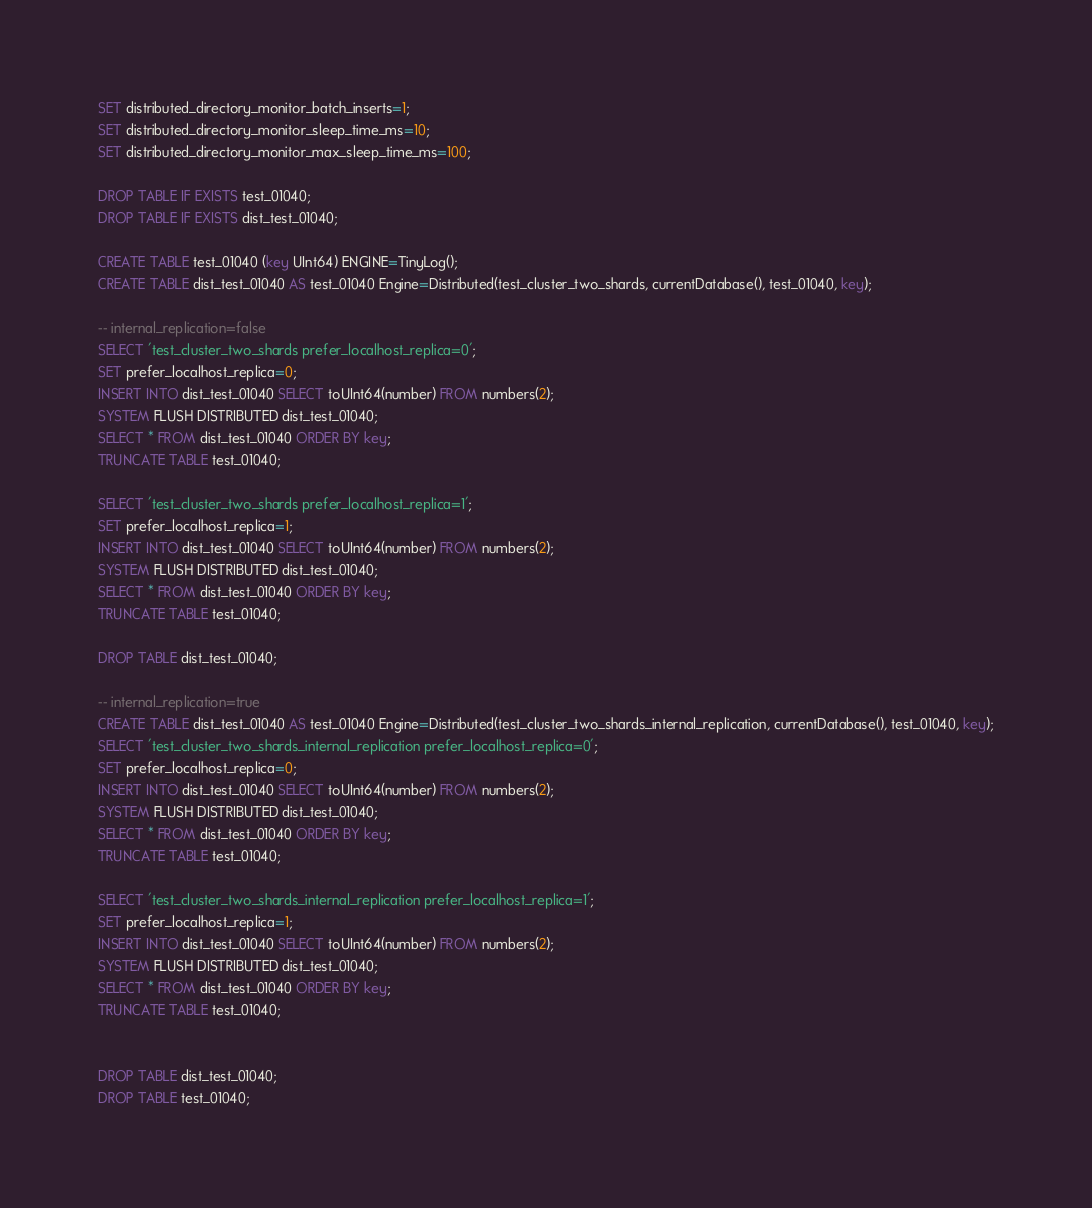Convert code to text. <code><loc_0><loc_0><loc_500><loc_500><_SQL_>SET distributed_directory_monitor_batch_inserts=1;
SET distributed_directory_monitor_sleep_time_ms=10;
SET distributed_directory_monitor_max_sleep_time_ms=100;

DROP TABLE IF EXISTS test_01040;
DROP TABLE IF EXISTS dist_test_01040;

CREATE TABLE test_01040 (key UInt64) ENGINE=TinyLog();
CREATE TABLE dist_test_01040 AS test_01040 Engine=Distributed(test_cluster_two_shards, currentDatabase(), test_01040, key);

-- internal_replication=false
SELECT 'test_cluster_two_shards prefer_localhost_replica=0';
SET prefer_localhost_replica=0;
INSERT INTO dist_test_01040 SELECT toUInt64(number) FROM numbers(2);
SYSTEM FLUSH DISTRIBUTED dist_test_01040;
SELECT * FROM dist_test_01040 ORDER BY key;
TRUNCATE TABLE test_01040;

SELECT 'test_cluster_two_shards prefer_localhost_replica=1';
SET prefer_localhost_replica=1;
INSERT INTO dist_test_01040 SELECT toUInt64(number) FROM numbers(2);
SYSTEM FLUSH DISTRIBUTED dist_test_01040;
SELECT * FROM dist_test_01040 ORDER BY key;
TRUNCATE TABLE test_01040;

DROP TABLE dist_test_01040;

-- internal_replication=true
CREATE TABLE dist_test_01040 AS test_01040 Engine=Distributed(test_cluster_two_shards_internal_replication, currentDatabase(), test_01040, key);
SELECT 'test_cluster_two_shards_internal_replication prefer_localhost_replica=0';
SET prefer_localhost_replica=0;
INSERT INTO dist_test_01040 SELECT toUInt64(number) FROM numbers(2);
SYSTEM FLUSH DISTRIBUTED dist_test_01040;
SELECT * FROM dist_test_01040 ORDER BY key;
TRUNCATE TABLE test_01040;

SELECT 'test_cluster_two_shards_internal_replication prefer_localhost_replica=1';
SET prefer_localhost_replica=1;
INSERT INTO dist_test_01040 SELECT toUInt64(number) FROM numbers(2);
SYSTEM FLUSH DISTRIBUTED dist_test_01040;
SELECT * FROM dist_test_01040 ORDER BY key;
TRUNCATE TABLE test_01040;


DROP TABLE dist_test_01040;
DROP TABLE test_01040;
</code> 